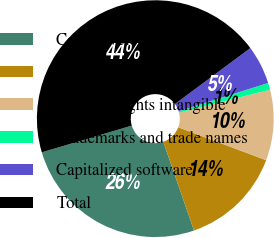Convert chart. <chart><loc_0><loc_0><loc_500><loc_500><pie_chart><fcel>Core/developed technology<fcel>Customer relationships<fcel>Contract rights intangible<fcel>Trademarks and trade names<fcel>Capitalized software<fcel>Total<nl><fcel>25.71%<fcel>13.99%<fcel>9.64%<fcel>0.94%<fcel>5.29%<fcel>44.43%<nl></chart> 